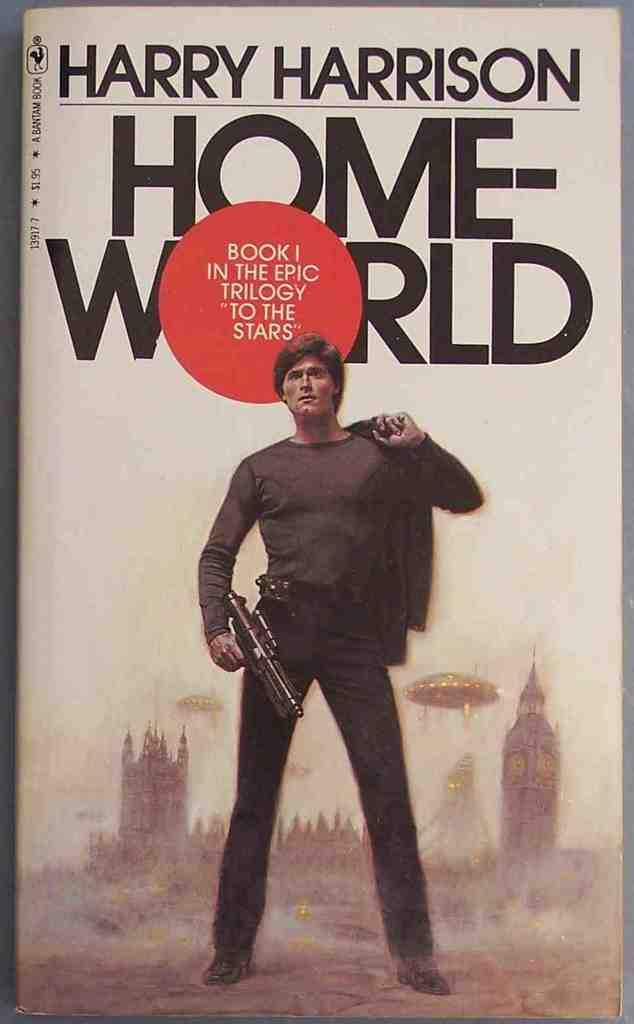What object is present in the image? There is a book in the image. What is depicted on the cover of the book? The book has an image of a person holding a gun and cloth. Are there any words on the book? Yes, there is text on the book. What else can be seen on the book besides the image and text? There are buildings depicted on the book. What type of straw is being used to clean the sink in the image? There is no sink or straw present in the image; it features a book with an image of a person holding a gun and cloth. 